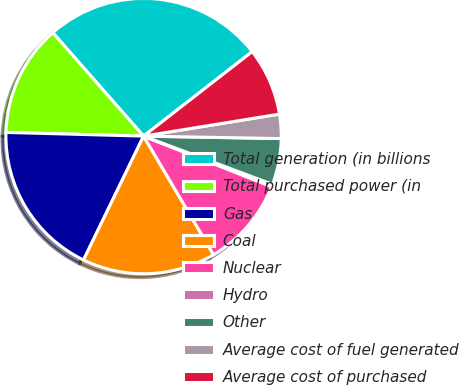<chart> <loc_0><loc_0><loc_500><loc_500><pie_chart><fcel>Total generation (in billions<fcel>Total purchased power (in<fcel>Gas<fcel>Coal<fcel>Nuclear<fcel>Hydro<fcel>Other<fcel>Average cost of fuel generated<fcel>Average cost of purchased<nl><fcel>25.94%<fcel>13.11%<fcel>18.24%<fcel>15.67%<fcel>10.54%<fcel>0.28%<fcel>5.41%<fcel>2.84%<fcel>7.97%<nl></chart> 